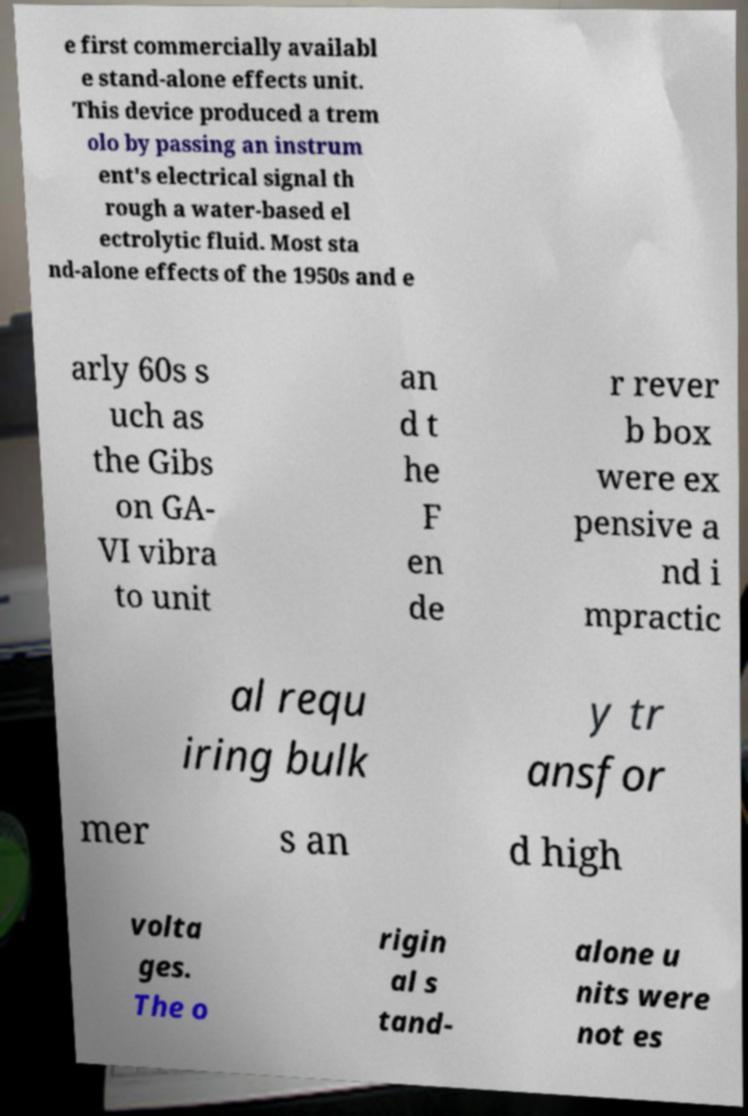There's text embedded in this image that I need extracted. Can you transcribe it verbatim? e first commercially availabl e stand-alone effects unit. This device produced a trem olo by passing an instrum ent's electrical signal th rough a water-based el ectrolytic fluid. Most sta nd-alone effects of the 1950s and e arly 60s s uch as the Gibs on GA- VI vibra to unit an d t he F en de r rever b box were ex pensive a nd i mpractic al requ iring bulk y tr ansfor mer s an d high volta ges. The o rigin al s tand- alone u nits were not es 